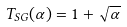<formula> <loc_0><loc_0><loc_500><loc_500>T _ { S G } ( \alpha ) = 1 + \sqrt { \alpha }</formula> 